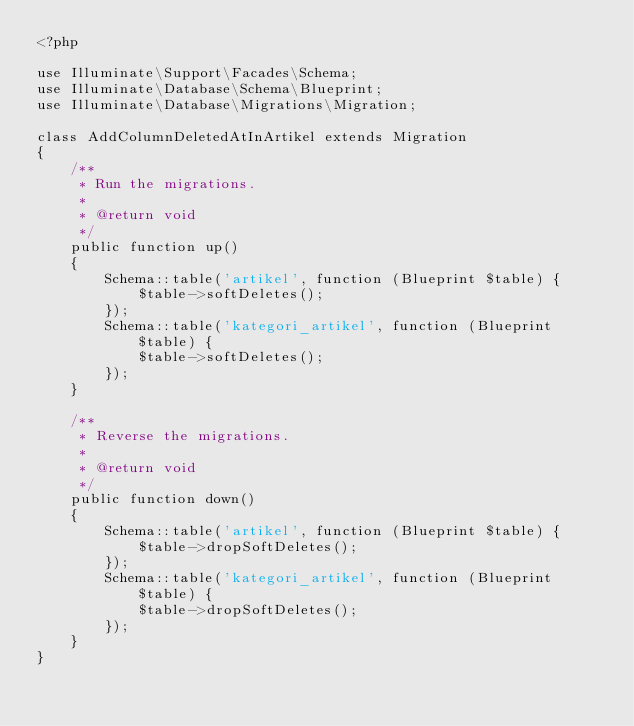<code> <loc_0><loc_0><loc_500><loc_500><_PHP_><?php

use Illuminate\Support\Facades\Schema;
use Illuminate\Database\Schema\Blueprint;
use Illuminate\Database\Migrations\Migration;

class AddColumnDeletedAtInArtikel extends Migration
{
    /**
     * Run the migrations.
     *
     * @return void
     */
    public function up()
    {
        Schema::table('artikel', function (Blueprint $table) {
            $table->softDeletes();
        });
        Schema::table('kategori_artikel', function (Blueprint $table) {
            $table->softDeletes();
        });
    }

    /**
     * Reverse the migrations.
     *
     * @return void
     */
    public function down()
    {
        Schema::table('artikel', function (Blueprint $table) {
            $table->dropSoftDeletes();
        });
        Schema::table('kategori_artikel', function (Blueprint $table) {
            $table->dropSoftDeletes();
        });
    }
}
</code> 